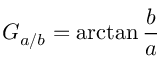<formula> <loc_0><loc_0><loc_500><loc_500>G _ { a / b } = \arctan { \frac { b } { a } }</formula> 